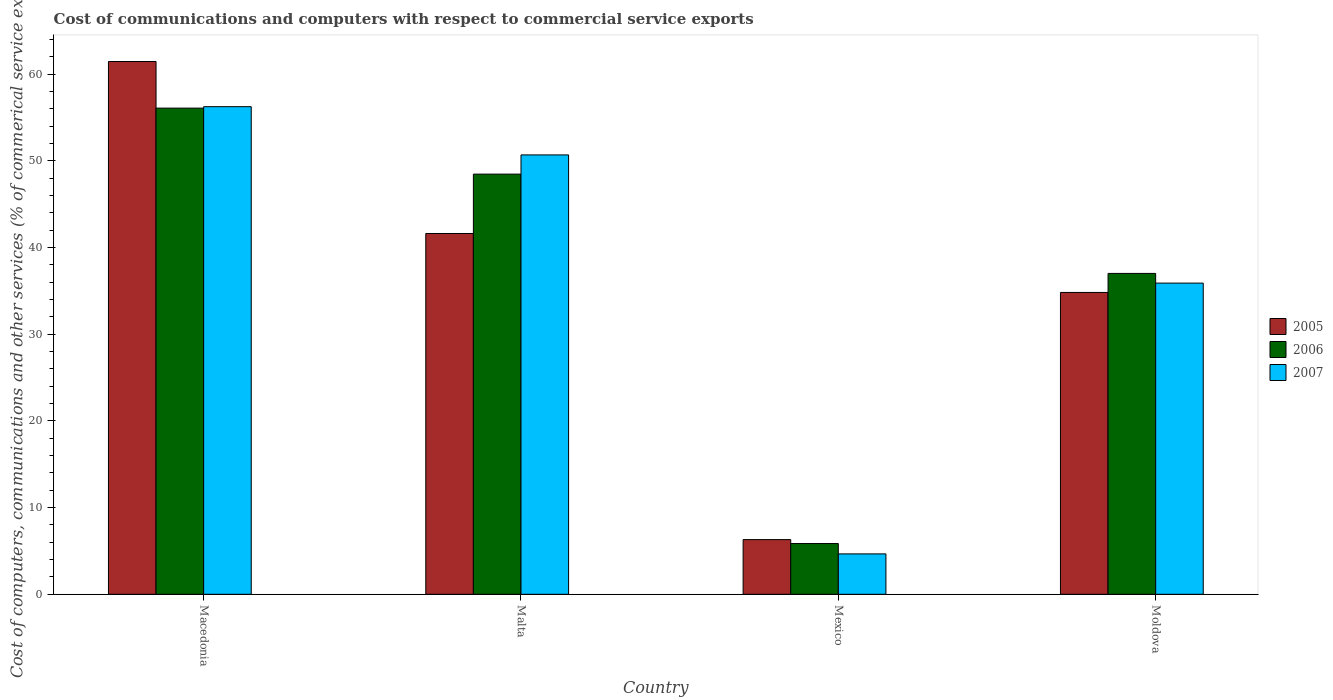How many different coloured bars are there?
Provide a short and direct response. 3. Are the number of bars per tick equal to the number of legend labels?
Offer a very short reply. Yes. Are the number of bars on each tick of the X-axis equal?
Provide a short and direct response. Yes. How many bars are there on the 1st tick from the right?
Offer a very short reply. 3. What is the label of the 3rd group of bars from the left?
Keep it short and to the point. Mexico. What is the cost of communications and computers in 2005 in Macedonia?
Make the answer very short. 61.46. Across all countries, what is the maximum cost of communications and computers in 2005?
Make the answer very short. 61.46. Across all countries, what is the minimum cost of communications and computers in 2005?
Ensure brevity in your answer.  6.31. In which country was the cost of communications and computers in 2007 maximum?
Make the answer very short. Macedonia. What is the total cost of communications and computers in 2005 in the graph?
Your response must be concise. 144.22. What is the difference between the cost of communications and computers in 2005 in Malta and that in Mexico?
Offer a very short reply. 35.31. What is the difference between the cost of communications and computers in 2006 in Moldova and the cost of communications and computers in 2005 in Macedonia?
Offer a terse response. -24.45. What is the average cost of communications and computers in 2006 per country?
Your response must be concise. 36.86. What is the difference between the cost of communications and computers of/in 2006 and cost of communications and computers of/in 2005 in Mexico?
Your response must be concise. -0.45. In how many countries, is the cost of communications and computers in 2007 greater than 58 %?
Ensure brevity in your answer.  0. What is the ratio of the cost of communications and computers in 2005 in Macedonia to that in Malta?
Offer a very short reply. 1.48. What is the difference between the highest and the second highest cost of communications and computers in 2005?
Make the answer very short. 6.8. What is the difference between the highest and the lowest cost of communications and computers in 2005?
Offer a terse response. 55.15. What does the 2nd bar from the left in Malta represents?
Give a very brief answer. 2006. Is it the case that in every country, the sum of the cost of communications and computers in 2007 and cost of communications and computers in 2006 is greater than the cost of communications and computers in 2005?
Give a very brief answer. Yes. How many bars are there?
Your answer should be very brief. 12. What is the difference between two consecutive major ticks on the Y-axis?
Keep it short and to the point. 10. Does the graph contain grids?
Ensure brevity in your answer.  No. Where does the legend appear in the graph?
Keep it short and to the point. Center right. How many legend labels are there?
Offer a very short reply. 3. What is the title of the graph?
Offer a terse response. Cost of communications and computers with respect to commercial service exports. Does "1968" appear as one of the legend labels in the graph?
Provide a short and direct response. No. What is the label or title of the Y-axis?
Ensure brevity in your answer.  Cost of computers, communications and other services (% of commerical service exports). What is the Cost of computers, communications and other services (% of commerical service exports) in 2005 in Macedonia?
Ensure brevity in your answer.  61.46. What is the Cost of computers, communications and other services (% of commerical service exports) of 2006 in Macedonia?
Keep it short and to the point. 56.09. What is the Cost of computers, communications and other services (% of commerical service exports) of 2007 in Macedonia?
Your response must be concise. 56.25. What is the Cost of computers, communications and other services (% of commerical service exports) of 2005 in Malta?
Make the answer very short. 41.62. What is the Cost of computers, communications and other services (% of commerical service exports) in 2006 in Malta?
Your answer should be very brief. 48.47. What is the Cost of computers, communications and other services (% of commerical service exports) of 2007 in Malta?
Your response must be concise. 50.69. What is the Cost of computers, communications and other services (% of commerical service exports) of 2005 in Mexico?
Offer a terse response. 6.31. What is the Cost of computers, communications and other services (% of commerical service exports) in 2006 in Mexico?
Your response must be concise. 5.85. What is the Cost of computers, communications and other services (% of commerical service exports) of 2007 in Mexico?
Your response must be concise. 4.66. What is the Cost of computers, communications and other services (% of commerical service exports) in 2005 in Moldova?
Provide a succinct answer. 34.82. What is the Cost of computers, communications and other services (% of commerical service exports) in 2006 in Moldova?
Keep it short and to the point. 37.02. What is the Cost of computers, communications and other services (% of commerical service exports) in 2007 in Moldova?
Your answer should be very brief. 35.9. Across all countries, what is the maximum Cost of computers, communications and other services (% of commerical service exports) in 2005?
Your response must be concise. 61.46. Across all countries, what is the maximum Cost of computers, communications and other services (% of commerical service exports) of 2006?
Provide a short and direct response. 56.09. Across all countries, what is the maximum Cost of computers, communications and other services (% of commerical service exports) of 2007?
Provide a short and direct response. 56.25. Across all countries, what is the minimum Cost of computers, communications and other services (% of commerical service exports) in 2005?
Keep it short and to the point. 6.31. Across all countries, what is the minimum Cost of computers, communications and other services (% of commerical service exports) in 2006?
Your answer should be compact. 5.85. Across all countries, what is the minimum Cost of computers, communications and other services (% of commerical service exports) of 2007?
Keep it short and to the point. 4.66. What is the total Cost of computers, communications and other services (% of commerical service exports) in 2005 in the graph?
Give a very brief answer. 144.22. What is the total Cost of computers, communications and other services (% of commerical service exports) in 2006 in the graph?
Ensure brevity in your answer.  147.43. What is the total Cost of computers, communications and other services (% of commerical service exports) in 2007 in the graph?
Your answer should be very brief. 147.5. What is the difference between the Cost of computers, communications and other services (% of commerical service exports) of 2005 in Macedonia and that in Malta?
Your answer should be very brief. 19.84. What is the difference between the Cost of computers, communications and other services (% of commerical service exports) of 2006 in Macedonia and that in Malta?
Give a very brief answer. 7.61. What is the difference between the Cost of computers, communications and other services (% of commerical service exports) in 2007 in Macedonia and that in Malta?
Offer a very short reply. 5.56. What is the difference between the Cost of computers, communications and other services (% of commerical service exports) of 2005 in Macedonia and that in Mexico?
Your answer should be compact. 55.15. What is the difference between the Cost of computers, communications and other services (% of commerical service exports) in 2006 in Macedonia and that in Mexico?
Provide a short and direct response. 50.23. What is the difference between the Cost of computers, communications and other services (% of commerical service exports) in 2007 in Macedonia and that in Mexico?
Make the answer very short. 51.59. What is the difference between the Cost of computers, communications and other services (% of commerical service exports) in 2005 in Macedonia and that in Moldova?
Offer a terse response. 26.64. What is the difference between the Cost of computers, communications and other services (% of commerical service exports) in 2006 in Macedonia and that in Moldova?
Provide a succinct answer. 19.07. What is the difference between the Cost of computers, communications and other services (% of commerical service exports) of 2007 in Macedonia and that in Moldova?
Ensure brevity in your answer.  20.35. What is the difference between the Cost of computers, communications and other services (% of commerical service exports) in 2005 in Malta and that in Mexico?
Keep it short and to the point. 35.31. What is the difference between the Cost of computers, communications and other services (% of commerical service exports) of 2006 in Malta and that in Mexico?
Your response must be concise. 42.62. What is the difference between the Cost of computers, communications and other services (% of commerical service exports) of 2007 in Malta and that in Mexico?
Offer a very short reply. 46.03. What is the difference between the Cost of computers, communications and other services (% of commerical service exports) in 2005 in Malta and that in Moldova?
Offer a terse response. 6.8. What is the difference between the Cost of computers, communications and other services (% of commerical service exports) of 2006 in Malta and that in Moldova?
Provide a short and direct response. 11.46. What is the difference between the Cost of computers, communications and other services (% of commerical service exports) in 2007 in Malta and that in Moldova?
Make the answer very short. 14.79. What is the difference between the Cost of computers, communications and other services (% of commerical service exports) in 2005 in Mexico and that in Moldova?
Provide a succinct answer. -28.51. What is the difference between the Cost of computers, communications and other services (% of commerical service exports) of 2006 in Mexico and that in Moldova?
Provide a short and direct response. -31.16. What is the difference between the Cost of computers, communications and other services (% of commerical service exports) in 2007 in Mexico and that in Moldova?
Your answer should be very brief. -31.24. What is the difference between the Cost of computers, communications and other services (% of commerical service exports) in 2005 in Macedonia and the Cost of computers, communications and other services (% of commerical service exports) in 2006 in Malta?
Ensure brevity in your answer.  12.99. What is the difference between the Cost of computers, communications and other services (% of commerical service exports) in 2005 in Macedonia and the Cost of computers, communications and other services (% of commerical service exports) in 2007 in Malta?
Make the answer very short. 10.78. What is the difference between the Cost of computers, communications and other services (% of commerical service exports) in 2006 in Macedonia and the Cost of computers, communications and other services (% of commerical service exports) in 2007 in Malta?
Provide a short and direct response. 5.4. What is the difference between the Cost of computers, communications and other services (% of commerical service exports) of 2005 in Macedonia and the Cost of computers, communications and other services (% of commerical service exports) of 2006 in Mexico?
Offer a terse response. 55.61. What is the difference between the Cost of computers, communications and other services (% of commerical service exports) of 2005 in Macedonia and the Cost of computers, communications and other services (% of commerical service exports) of 2007 in Mexico?
Offer a terse response. 56.8. What is the difference between the Cost of computers, communications and other services (% of commerical service exports) of 2006 in Macedonia and the Cost of computers, communications and other services (% of commerical service exports) of 2007 in Mexico?
Your answer should be very brief. 51.43. What is the difference between the Cost of computers, communications and other services (% of commerical service exports) of 2005 in Macedonia and the Cost of computers, communications and other services (% of commerical service exports) of 2006 in Moldova?
Provide a short and direct response. 24.45. What is the difference between the Cost of computers, communications and other services (% of commerical service exports) of 2005 in Macedonia and the Cost of computers, communications and other services (% of commerical service exports) of 2007 in Moldova?
Give a very brief answer. 25.56. What is the difference between the Cost of computers, communications and other services (% of commerical service exports) of 2006 in Macedonia and the Cost of computers, communications and other services (% of commerical service exports) of 2007 in Moldova?
Your answer should be compact. 20.19. What is the difference between the Cost of computers, communications and other services (% of commerical service exports) in 2005 in Malta and the Cost of computers, communications and other services (% of commerical service exports) in 2006 in Mexico?
Your answer should be very brief. 35.77. What is the difference between the Cost of computers, communications and other services (% of commerical service exports) in 2005 in Malta and the Cost of computers, communications and other services (% of commerical service exports) in 2007 in Mexico?
Ensure brevity in your answer.  36.96. What is the difference between the Cost of computers, communications and other services (% of commerical service exports) in 2006 in Malta and the Cost of computers, communications and other services (% of commerical service exports) in 2007 in Mexico?
Your answer should be very brief. 43.81. What is the difference between the Cost of computers, communications and other services (% of commerical service exports) in 2005 in Malta and the Cost of computers, communications and other services (% of commerical service exports) in 2006 in Moldova?
Your answer should be very brief. 4.61. What is the difference between the Cost of computers, communications and other services (% of commerical service exports) in 2005 in Malta and the Cost of computers, communications and other services (% of commerical service exports) in 2007 in Moldova?
Offer a very short reply. 5.72. What is the difference between the Cost of computers, communications and other services (% of commerical service exports) of 2006 in Malta and the Cost of computers, communications and other services (% of commerical service exports) of 2007 in Moldova?
Offer a very short reply. 12.57. What is the difference between the Cost of computers, communications and other services (% of commerical service exports) in 2005 in Mexico and the Cost of computers, communications and other services (% of commerical service exports) in 2006 in Moldova?
Your answer should be compact. -30.71. What is the difference between the Cost of computers, communications and other services (% of commerical service exports) in 2005 in Mexico and the Cost of computers, communications and other services (% of commerical service exports) in 2007 in Moldova?
Offer a terse response. -29.59. What is the difference between the Cost of computers, communications and other services (% of commerical service exports) of 2006 in Mexico and the Cost of computers, communications and other services (% of commerical service exports) of 2007 in Moldova?
Your answer should be very brief. -30.04. What is the average Cost of computers, communications and other services (% of commerical service exports) in 2005 per country?
Give a very brief answer. 36.05. What is the average Cost of computers, communications and other services (% of commerical service exports) of 2006 per country?
Offer a terse response. 36.86. What is the average Cost of computers, communications and other services (% of commerical service exports) in 2007 per country?
Provide a short and direct response. 36.87. What is the difference between the Cost of computers, communications and other services (% of commerical service exports) of 2005 and Cost of computers, communications and other services (% of commerical service exports) of 2006 in Macedonia?
Your answer should be very brief. 5.38. What is the difference between the Cost of computers, communications and other services (% of commerical service exports) in 2005 and Cost of computers, communications and other services (% of commerical service exports) in 2007 in Macedonia?
Keep it short and to the point. 5.21. What is the difference between the Cost of computers, communications and other services (% of commerical service exports) of 2006 and Cost of computers, communications and other services (% of commerical service exports) of 2007 in Macedonia?
Give a very brief answer. -0.17. What is the difference between the Cost of computers, communications and other services (% of commerical service exports) in 2005 and Cost of computers, communications and other services (% of commerical service exports) in 2006 in Malta?
Provide a short and direct response. -6.85. What is the difference between the Cost of computers, communications and other services (% of commerical service exports) in 2005 and Cost of computers, communications and other services (% of commerical service exports) in 2007 in Malta?
Keep it short and to the point. -9.07. What is the difference between the Cost of computers, communications and other services (% of commerical service exports) in 2006 and Cost of computers, communications and other services (% of commerical service exports) in 2007 in Malta?
Your response must be concise. -2.21. What is the difference between the Cost of computers, communications and other services (% of commerical service exports) of 2005 and Cost of computers, communications and other services (% of commerical service exports) of 2006 in Mexico?
Offer a very short reply. 0.45. What is the difference between the Cost of computers, communications and other services (% of commerical service exports) in 2005 and Cost of computers, communications and other services (% of commerical service exports) in 2007 in Mexico?
Give a very brief answer. 1.65. What is the difference between the Cost of computers, communications and other services (% of commerical service exports) of 2006 and Cost of computers, communications and other services (% of commerical service exports) of 2007 in Mexico?
Provide a succinct answer. 1.19. What is the difference between the Cost of computers, communications and other services (% of commerical service exports) in 2005 and Cost of computers, communications and other services (% of commerical service exports) in 2006 in Moldova?
Ensure brevity in your answer.  -2.19. What is the difference between the Cost of computers, communications and other services (% of commerical service exports) of 2005 and Cost of computers, communications and other services (% of commerical service exports) of 2007 in Moldova?
Provide a succinct answer. -1.08. What is the difference between the Cost of computers, communications and other services (% of commerical service exports) in 2006 and Cost of computers, communications and other services (% of commerical service exports) in 2007 in Moldova?
Keep it short and to the point. 1.12. What is the ratio of the Cost of computers, communications and other services (% of commerical service exports) in 2005 in Macedonia to that in Malta?
Give a very brief answer. 1.48. What is the ratio of the Cost of computers, communications and other services (% of commerical service exports) of 2006 in Macedonia to that in Malta?
Your response must be concise. 1.16. What is the ratio of the Cost of computers, communications and other services (% of commerical service exports) in 2007 in Macedonia to that in Malta?
Offer a terse response. 1.11. What is the ratio of the Cost of computers, communications and other services (% of commerical service exports) of 2005 in Macedonia to that in Mexico?
Keep it short and to the point. 9.74. What is the ratio of the Cost of computers, communications and other services (% of commerical service exports) in 2006 in Macedonia to that in Mexico?
Your response must be concise. 9.58. What is the ratio of the Cost of computers, communications and other services (% of commerical service exports) in 2007 in Macedonia to that in Mexico?
Provide a short and direct response. 12.07. What is the ratio of the Cost of computers, communications and other services (% of commerical service exports) in 2005 in Macedonia to that in Moldova?
Offer a very short reply. 1.76. What is the ratio of the Cost of computers, communications and other services (% of commerical service exports) in 2006 in Macedonia to that in Moldova?
Your answer should be very brief. 1.52. What is the ratio of the Cost of computers, communications and other services (% of commerical service exports) in 2007 in Macedonia to that in Moldova?
Keep it short and to the point. 1.57. What is the ratio of the Cost of computers, communications and other services (% of commerical service exports) in 2005 in Malta to that in Mexico?
Keep it short and to the point. 6.6. What is the ratio of the Cost of computers, communications and other services (% of commerical service exports) of 2006 in Malta to that in Mexico?
Provide a short and direct response. 8.28. What is the ratio of the Cost of computers, communications and other services (% of commerical service exports) of 2007 in Malta to that in Mexico?
Offer a terse response. 10.88. What is the ratio of the Cost of computers, communications and other services (% of commerical service exports) in 2005 in Malta to that in Moldova?
Offer a terse response. 1.2. What is the ratio of the Cost of computers, communications and other services (% of commerical service exports) in 2006 in Malta to that in Moldova?
Your answer should be compact. 1.31. What is the ratio of the Cost of computers, communications and other services (% of commerical service exports) in 2007 in Malta to that in Moldova?
Your response must be concise. 1.41. What is the ratio of the Cost of computers, communications and other services (% of commerical service exports) of 2005 in Mexico to that in Moldova?
Your response must be concise. 0.18. What is the ratio of the Cost of computers, communications and other services (% of commerical service exports) of 2006 in Mexico to that in Moldova?
Provide a short and direct response. 0.16. What is the ratio of the Cost of computers, communications and other services (% of commerical service exports) of 2007 in Mexico to that in Moldova?
Your response must be concise. 0.13. What is the difference between the highest and the second highest Cost of computers, communications and other services (% of commerical service exports) of 2005?
Your response must be concise. 19.84. What is the difference between the highest and the second highest Cost of computers, communications and other services (% of commerical service exports) in 2006?
Provide a succinct answer. 7.61. What is the difference between the highest and the second highest Cost of computers, communications and other services (% of commerical service exports) of 2007?
Provide a succinct answer. 5.56. What is the difference between the highest and the lowest Cost of computers, communications and other services (% of commerical service exports) of 2005?
Provide a short and direct response. 55.15. What is the difference between the highest and the lowest Cost of computers, communications and other services (% of commerical service exports) of 2006?
Your answer should be compact. 50.23. What is the difference between the highest and the lowest Cost of computers, communications and other services (% of commerical service exports) in 2007?
Provide a succinct answer. 51.59. 